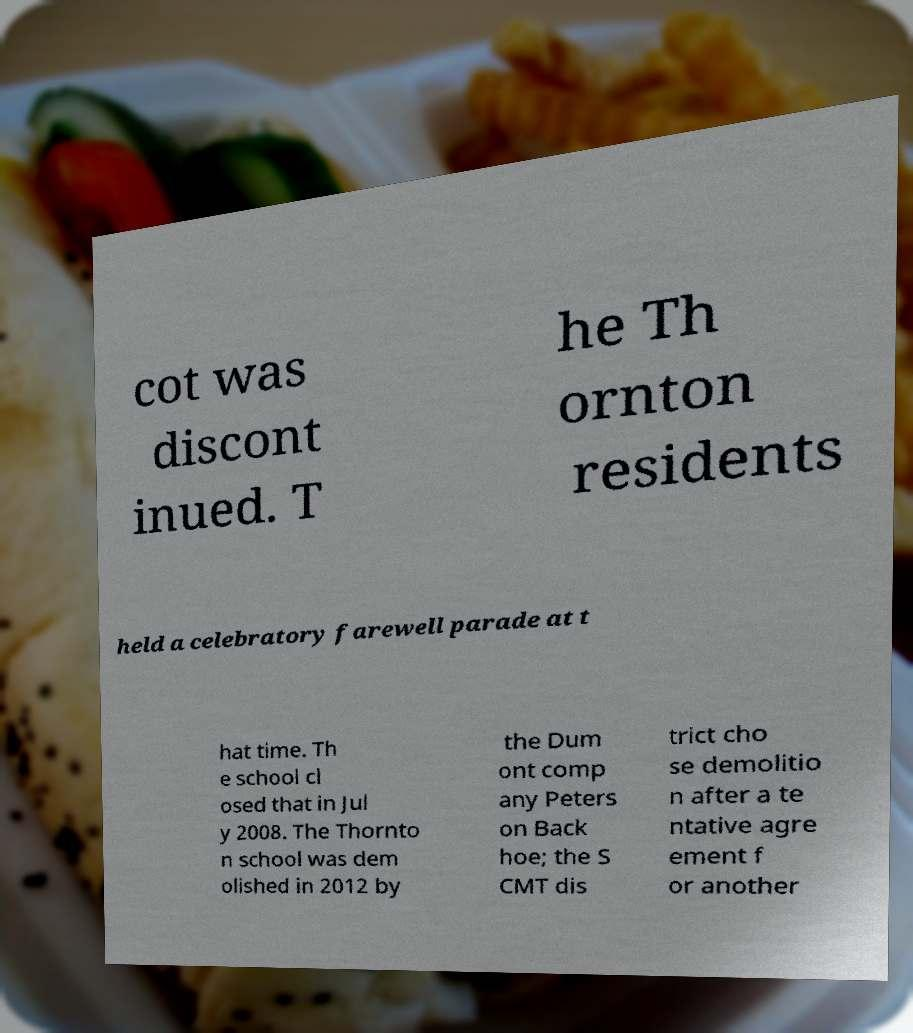Please read and relay the text visible in this image. What does it say? cot was discont inued. T he Th ornton residents held a celebratory farewell parade at t hat time. Th e school cl osed that in Jul y 2008. The Thornto n school was dem olished in 2012 by the Dum ont comp any Peters on Back hoe; the S CMT dis trict cho se demolitio n after a te ntative agre ement f or another 